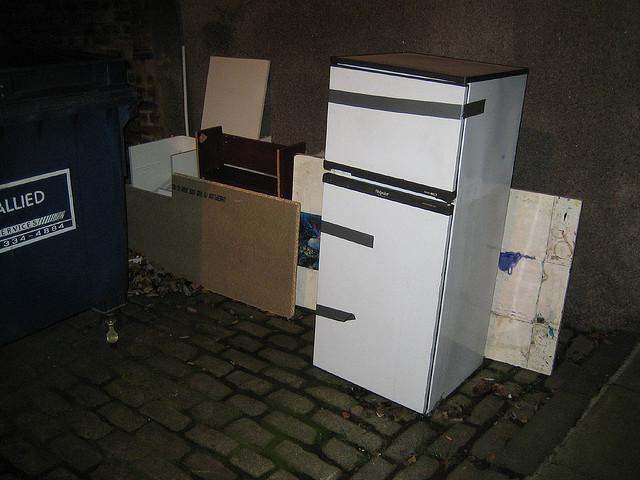Is there a cooling rack in this photo?
Give a very brief answer. No. What is next to the fridge?
Short answer required. Boxes. What can be written on board in this picture?
Answer briefly. Anything. What are the two devices in this picture?
Give a very brief answer. Fridge and freezer. Is the white appliance in the photo in current use?
Keep it brief. No. What is behind the refrigerators?
Short answer required. Wall. Is the appliance on the carpet?
Keep it brief. No. Where are packing boxes?
Keep it brief. Against wall. Why do the refrigerators need taped shut?
Short answer required. Safety. Is there food in the fridge?
Answer briefly. No. What color is the box?
Give a very brief answer. White. Does the refrigerator have an on the door ice dispenser?
Answer briefly. No. What color is the refrigerator?
Be succinct. White. 